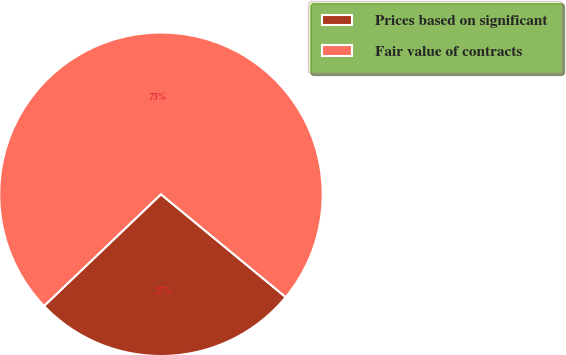<chart> <loc_0><loc_0><loc_500><loc_500><pie_chart><fcel>Prices based on significant<fcel>Fair value of contracts<nl><fcel>26.89%<fcel>73.11%<nl></chart> 